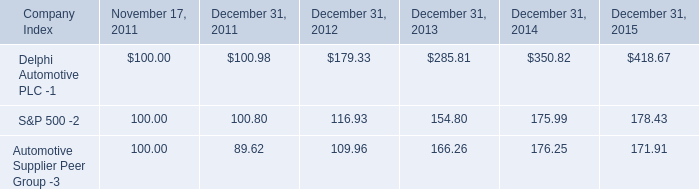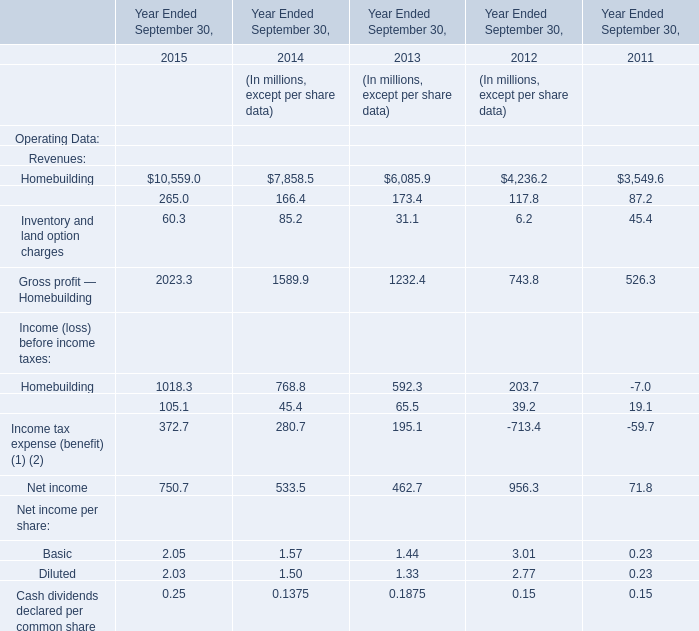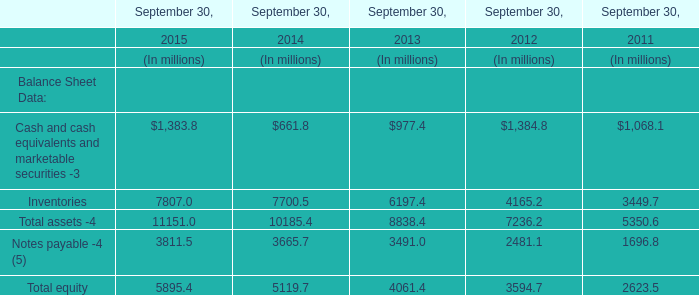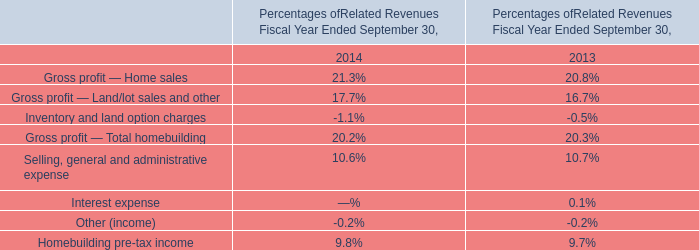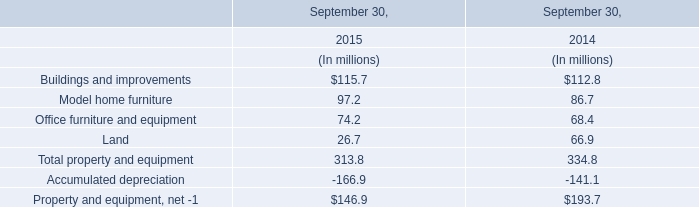In which year is Homebuilding smaller than Financial Services of Income (loss) before income taxes? 
Answer: 2011. 